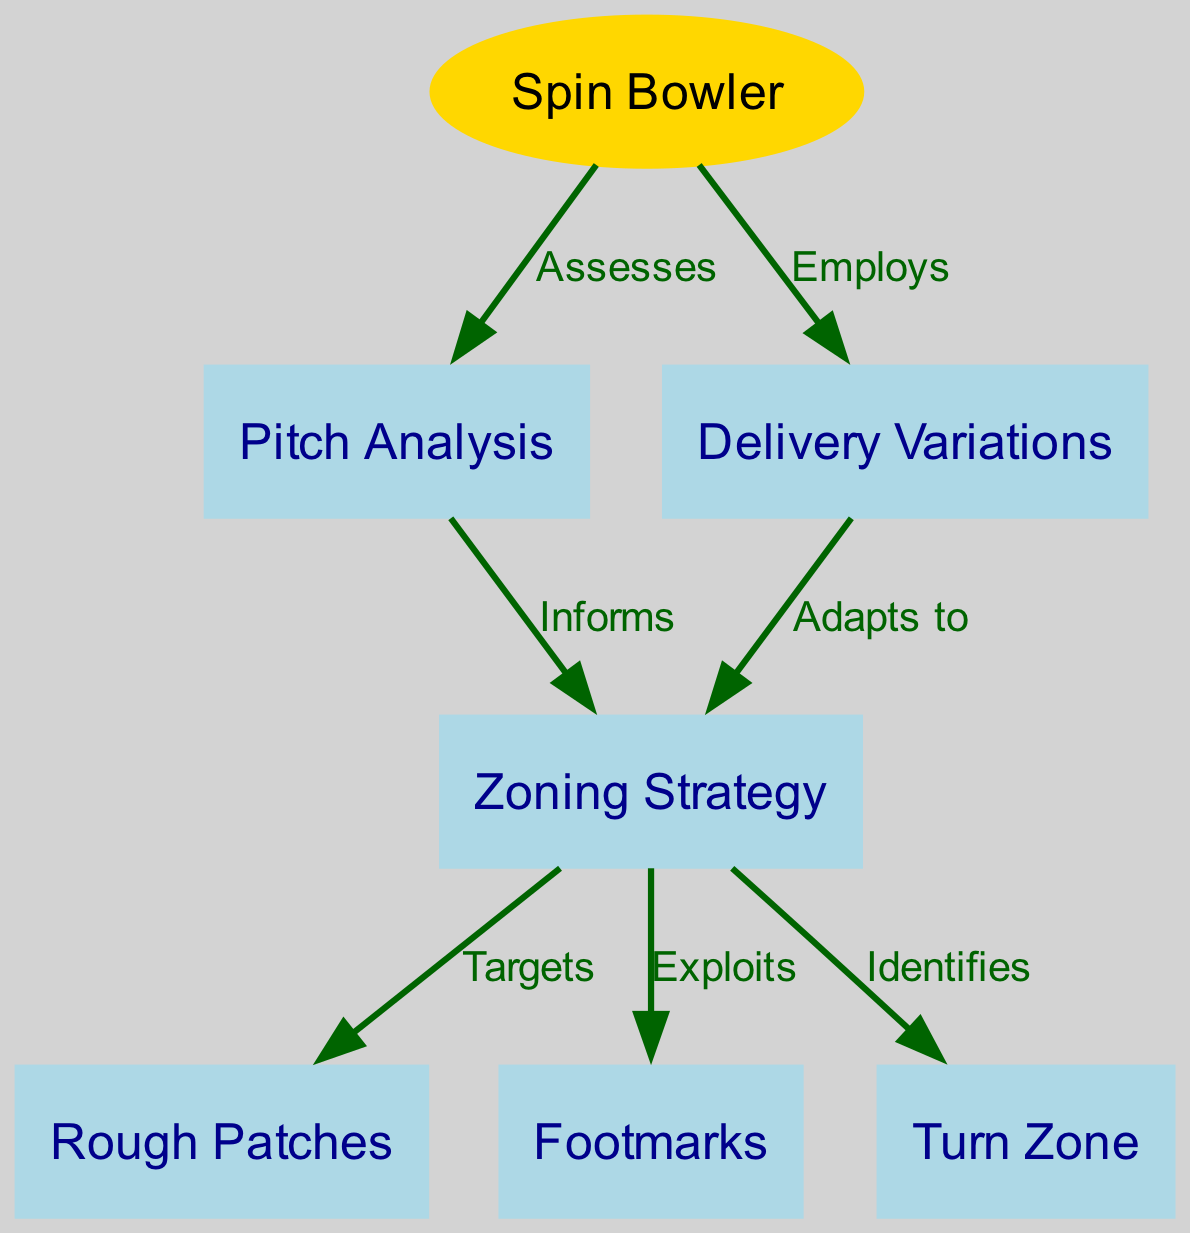What is the total number of nodes in the diagram? The diagram includes seven nodes: Spin Bowler, Pitch Analysis, Zoning Strategy, Rough Patches, Footmarks, Turn Zone, and Delivery Variations. Thus, when counted together, they give a total of 7 nodes.
Answer: 7 What type of node is Spin Bowler? In the diagram, the Spin Bowler node is represented as an ellipse, which is a specific shape chosen to highlight its importance compared to other nodes that are rectangles.
Answer: ellipse Which node does Zoning Strategy exploit? According to the diagram, the Zoning Strategy node has a direct edge labeled "Exploits" that connects it to the Footmarks node, indicating its focus on this aspect for strategic purposes.
Answer: Footmarks What relationship connects Pitch Analysis to Zoning Strategy? The diagram shows that Pitch Analysis has an edge labeled "Informs" that leads to Zoning Strategy, indicating that Pitch Analysis is providing essential information that shapes the Zoning Strategy.
Answer: Informs How many edges are in the diagram? Counting the connections (edges) that link the nodes, there are six edges shown in the diagram connecting different aspects of the spin bowling strategy from node to node.
Answer: 6 What does the Zoning Strategy target according to the diagram? The Zoning Strategy targets the Rough Patches per the diagram, as indicated by a direct edge labeled "Targets" from Zoning Strategy to Rough Patches. This shows an intentional focus on this specific area.
Answer: Rough Patches Which node does the Spin Bowler employ? The diagram illustrates that the Spin Bowler employs Delivery Variations, as there is an edge labeled "Employs" connecting the Spin Bowler directly to the Delivery Variations node, indicating its strategic use.
Answer: Delivery Variations What does Delivery Variations adapt to in the diagram? According to the diagram, Delivery Variations adapts to the Zoning Strategy, as noted by the edge labeled "Adapts to" that leads from Delivery Variations to Zoning Strategy, which indicates a responsive relationship.
Answer: Zoning Strategy What is the common theme among the nodes linked to Zoning Strategy? The common theme among nodes that connect to Zoning Strategy includes various tactical aspects of spin bowling (Rough Patches, Footmarks, and Turn Zone), emphasizing the focus on optimizing bowling strategies around these critical areas.
Answer: tactical aspects 